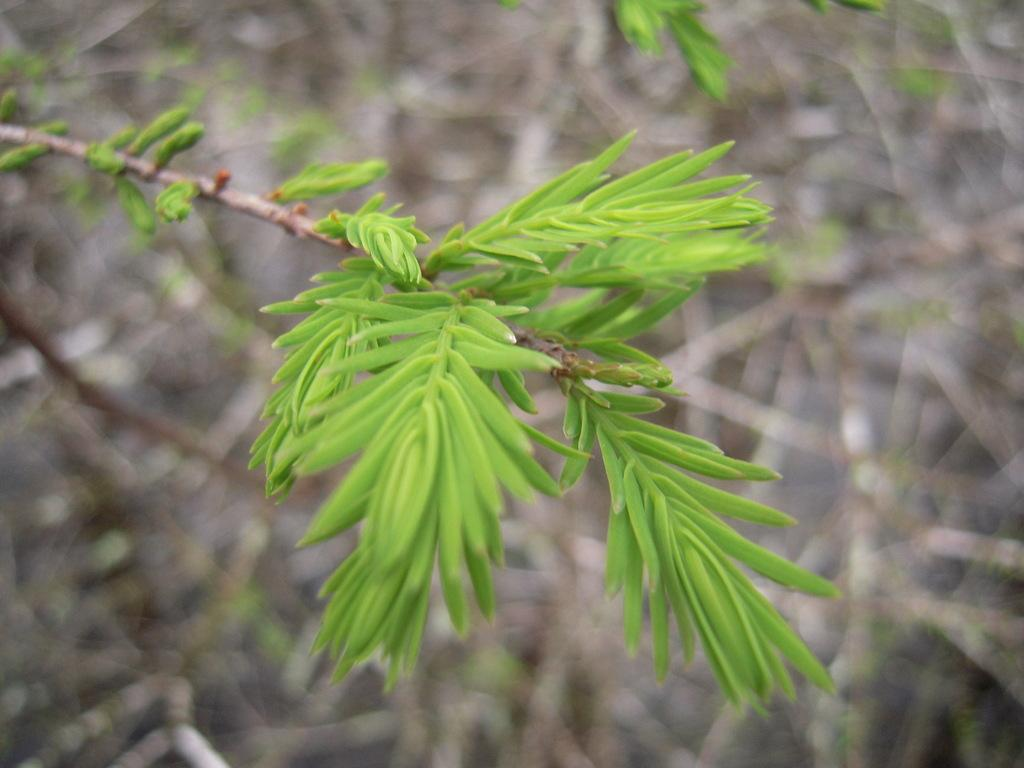What type of vegetation can be seen in the image? There are leaves in the image. What part of a tree can be seen in the image? There is a branch in the image. How many wings can be seen on the leaves in the image? There are no wings present on the leaves in the image, as leaves are part of plants and do not have wings. 